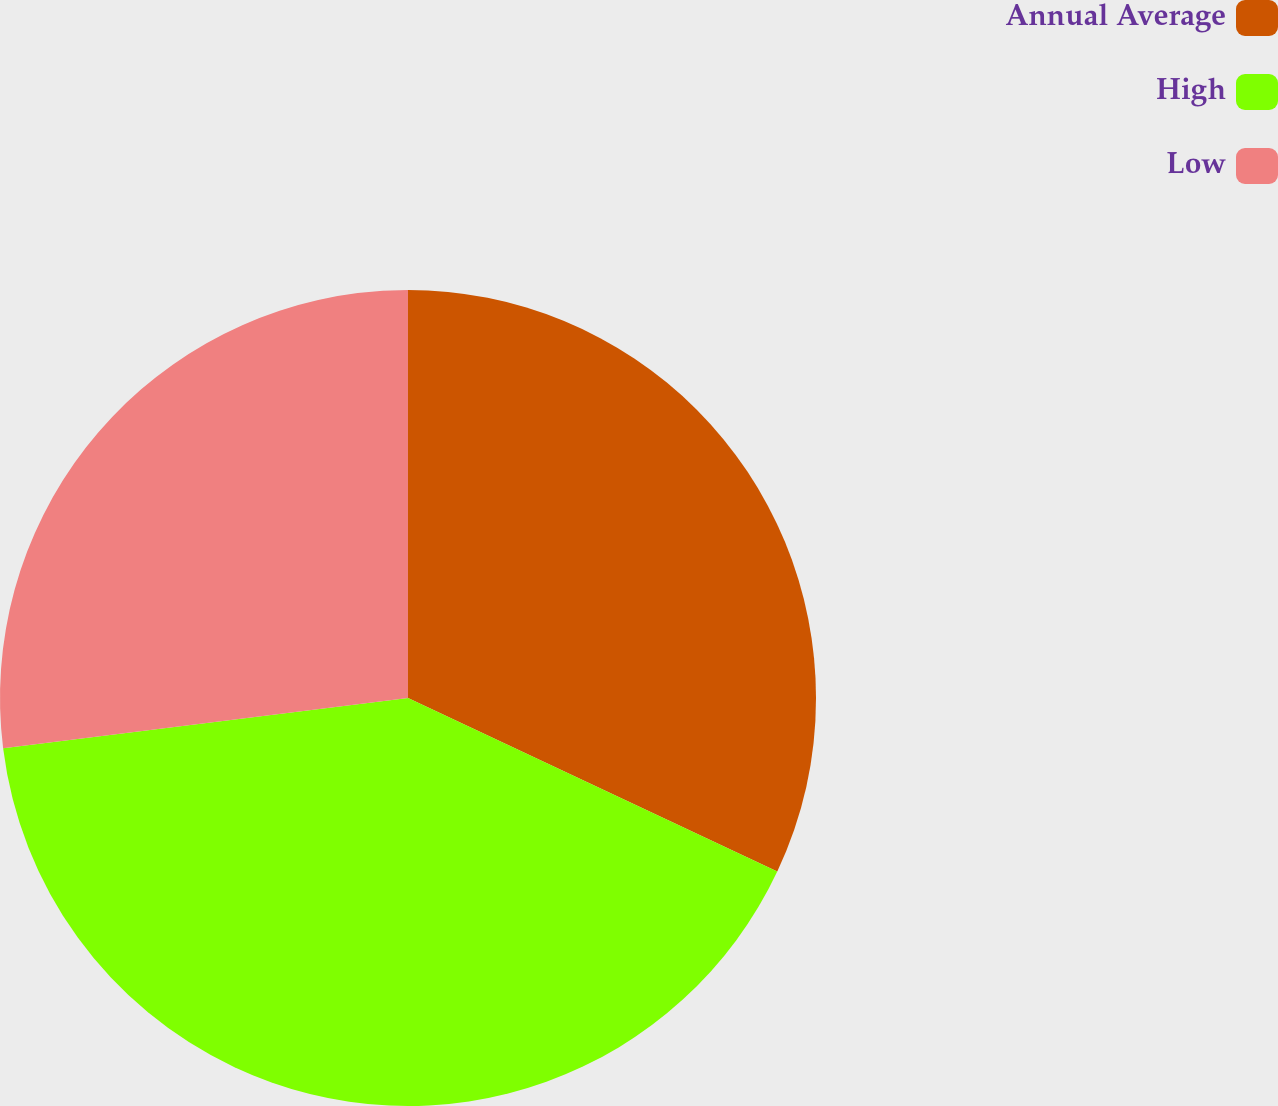<chart> <loc_0><loc_0><loc_500><loc_500><pie_chart><fcel>Annual Average<fcel>High<fcel>Low<nl><fcel>31.99%<fcel>41.04%<fcel>26.97%<nl></chart> 